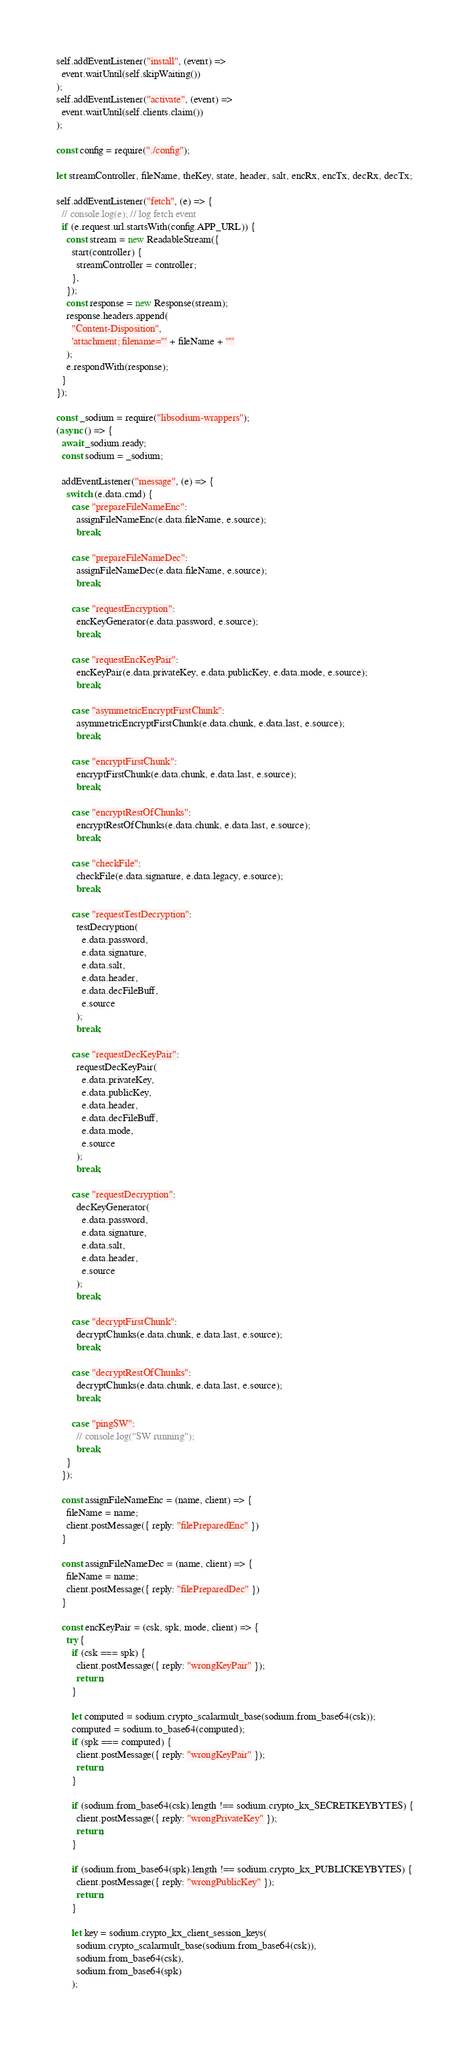<code> <loc_0><loc_0><loc_500><loc_500><_JavaScript_>self.addEventListener("install", (event) =>
  event.waitUntil(self.skipWaiting())
);
self.addEventListener("activate", (event) =>
  event.waitUntil(self.clients.claim())
);

const config = require("./config");

let streamController, fileName, theKey, state, header, salt, encRx, encTx, decRx, decTx;

self.addEventListener("fetch", (e) => {
  // console.log(e); // log fetch event
  if (e.request.url.startsWith(config.APP_URL)) {
    const stream = new ReadableStream({
      start(controller) {
        streamController = controller;
      },
    });
    const response = new Response(stream);
    response.headers.append(
      "Content-Disposition",
      'attachment; filename="' + fileName + '"'
    );
    e.respondWith(response);
  }
});

const _sodium = require("libsodium-wrappers");
(async () => {
  await _sodium.ready;
  const sodium = _sodium;

  addEventListener("message", (e) => {
    switch (e.data.cmd) {
      case "prepareFileNameEnc":
        assignFileNameEnc(e.data.fileName, e.source);
        break;

      case "prepareFileNameDec":
        assignFileNameDec(e.data.fileName, e.source);
        break;

      case "requestEncryption":
        encKeyGenerator(e.data.password, e.source);
        break;

      case "requestEncKeyPair":
        encKeyPair(e.data.privateKey, e.data.publicKey, e.data.mode, e.source);
        break;

      case "asymmetricEncryptFirstChunk":
        asymmetricEncryptFirstChunk(e.data.chunk, e.data.last, e.source);
        break;

      case "encryptFirstChunk":
        encryptFirstChunk(e.data.chunk, e.data.last, e.source);
        break;

      case "encryptRestOfChunks":
        encryptRestOfChunks(e.data.chunk, e.data.last, e.source);
        break;

      case "checkFile":
        checkFile(e.data.signature, e.data.legacy, e.source);
        break;

      case "requestTestDecryption":
        testDecryption(
          e.data.password,
          e.data.signature,
          e.data.salt,
          e.data.header,
          e.data.decFileBuff,
          e.source
        );
        break;

      case "requestDecKeyPair":
        requestDecKeyPair(
          e.data.privateKey,
          e.data.publicKey,
          e.data.header,
          e.data.decFileBuff,
          e.data.mode,
          e.source
        );
        break;

      case "requestDecryption":
        decKeyGenerator(
          e.data.password,
          e.data.signature,
          e.data.salt,
          e.data.header,
          e.source
        );
        break;

      case "decryptFirstChunk":
        decryptChunks(e.data.chunk, e.data.last, e.source);
        break;

      case "decryptRestOfChunks":
        decryptChunks(e.data.chunk, e.data.last, e.source);
        break;

      case "pingSW":
        // console.log("SW running");
        break;
    }
  });

  const assignFileNameEnc = (name, client) => {
    fileName = name;
    client.postMessage({ reply: "filePreparedEnc" })
  }

  const assignFileNameDec = (name, client) => {
    fileName = name;
    client.postMessage({ reply: "filePreparedDec" })
  }

  const encKeyPair = (csk, spk, mode, client) => {
    try {
      if (csk === spk) {
        client.postMessage({ reply: "wrongKeyPair" });
        return;
      }

      let computed = sodium.crypto_scalarmult_base(sodium.from_base64(csk));
      computed = sodium.to_base64(computed);
      if (spk === computed) {
        client.postMessage({ reply: "wrongKeyPair" });
        return;
      }

      if (sodium.from_base64(csk).length !== sodium.crypto_kx_SECRETKEYBYTES) {
        client.postMessage({ reply: "wrongPrivateKey" });
        return;
      }

      if (sodium.from_base64(spk).length !== sodium.crypto_kx_PUBLICKEYBYTES) {
        client.postMessage({ reply: "wrongPublicKey" });
        return;
      }

      let key = sodium.crypto_kx_client_session_keys(
        sodium.crypto_scalarmult_base(sodium.from_base64(csk)),
        sodium.from_base64(csk),
        sodium.from_base64(spk)
      );
</code> 